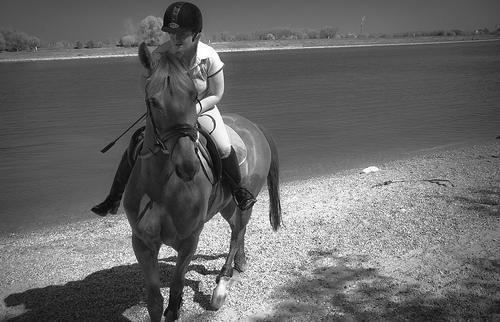How many horses in the picture?
Give a very brief answer. 1. 